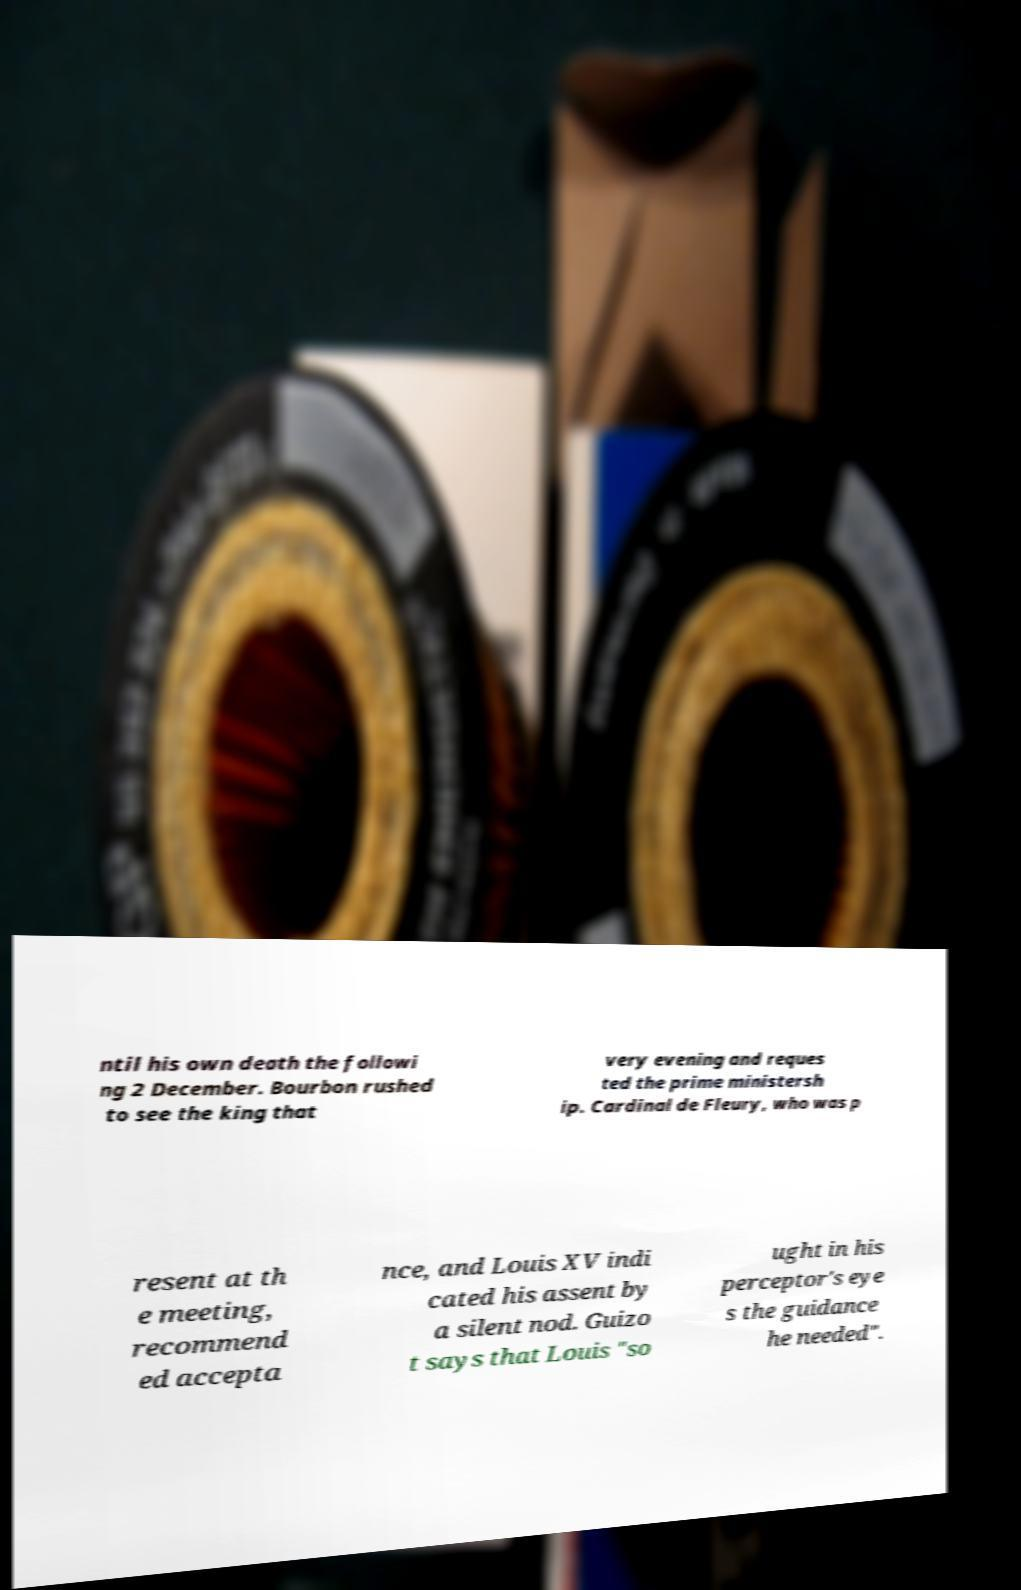For documentation purposes, I need the text within this image transcribed. Could you provide that? ntil his own death the followi ng 2 December. Bourbon rushed to see the king that very evening and reques ted the prime ministersh ip. Cardinal de Fleury, who was p resent at th e meeting, recommend ed accepta nce, and Louis XV indi cated his assent by a silent nod. Guizo t says that Louis "so ught in his perceptor's eye s the guidance he needed". 